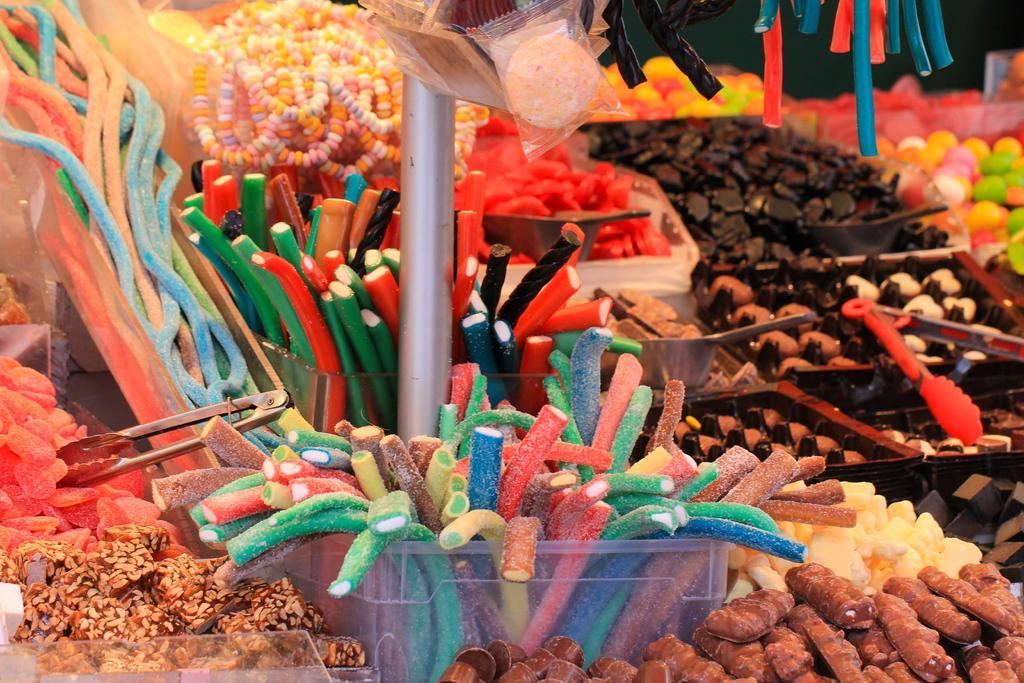Please provide a concise description of this image. In this image, we can see candies and there are some sugar candies, holders, trays and we can see a stand. 